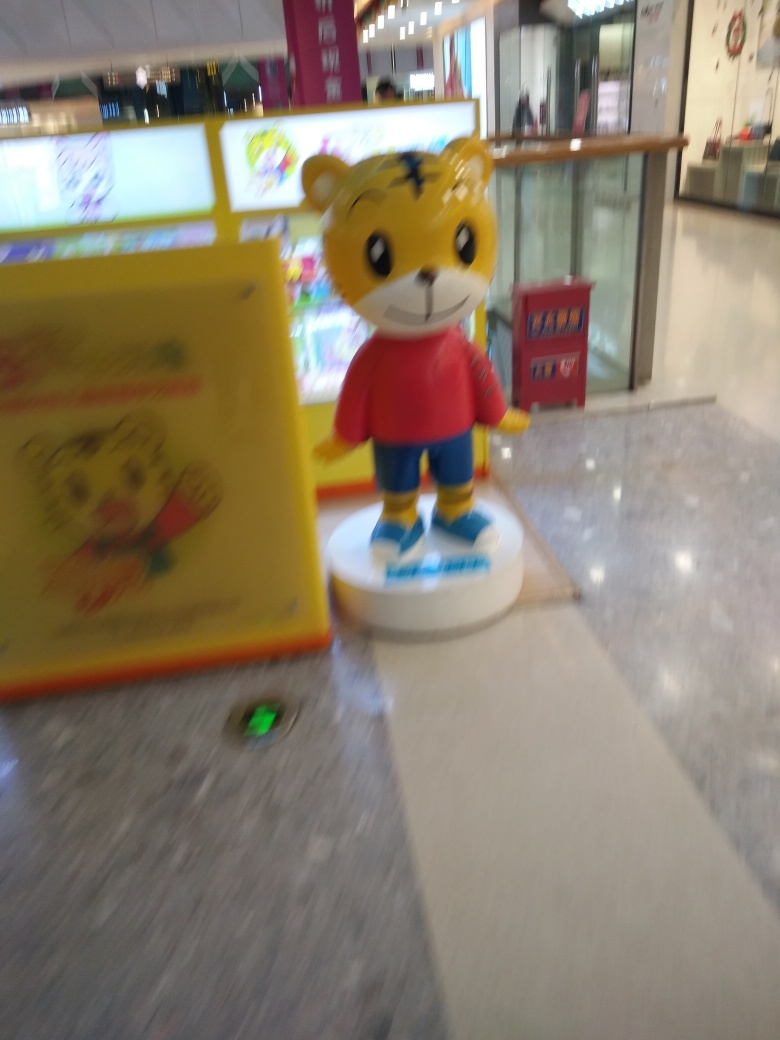Is this character known from any particular media or brand? Based on the visible design, it is possible the character could be associated with a specific brand, product, or media such as a children's cartoon or book series. Unfortunately, due to the lack of distinct recognizable features in this specific image, it's challenging to identify the character's exact origins. 